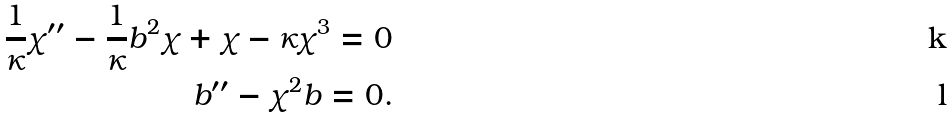<formula> <loc_0><loc_0><loc_500><loc_500>\frac { 1 } { \kappa } \chi ^ { \prime \prime } - \frac { 1 } { \kappa } b ^ { 2 } \chi + \chi - \kappa \chi ^ { 3 } = 0 \\ b ^ { \prime \prime } - \chi ^ { 2 } b = 0 .</formula> 